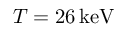<formula> <loc_0><loc_0><loc_500><loc_500>T = 2 6 \, k e V</formula> 